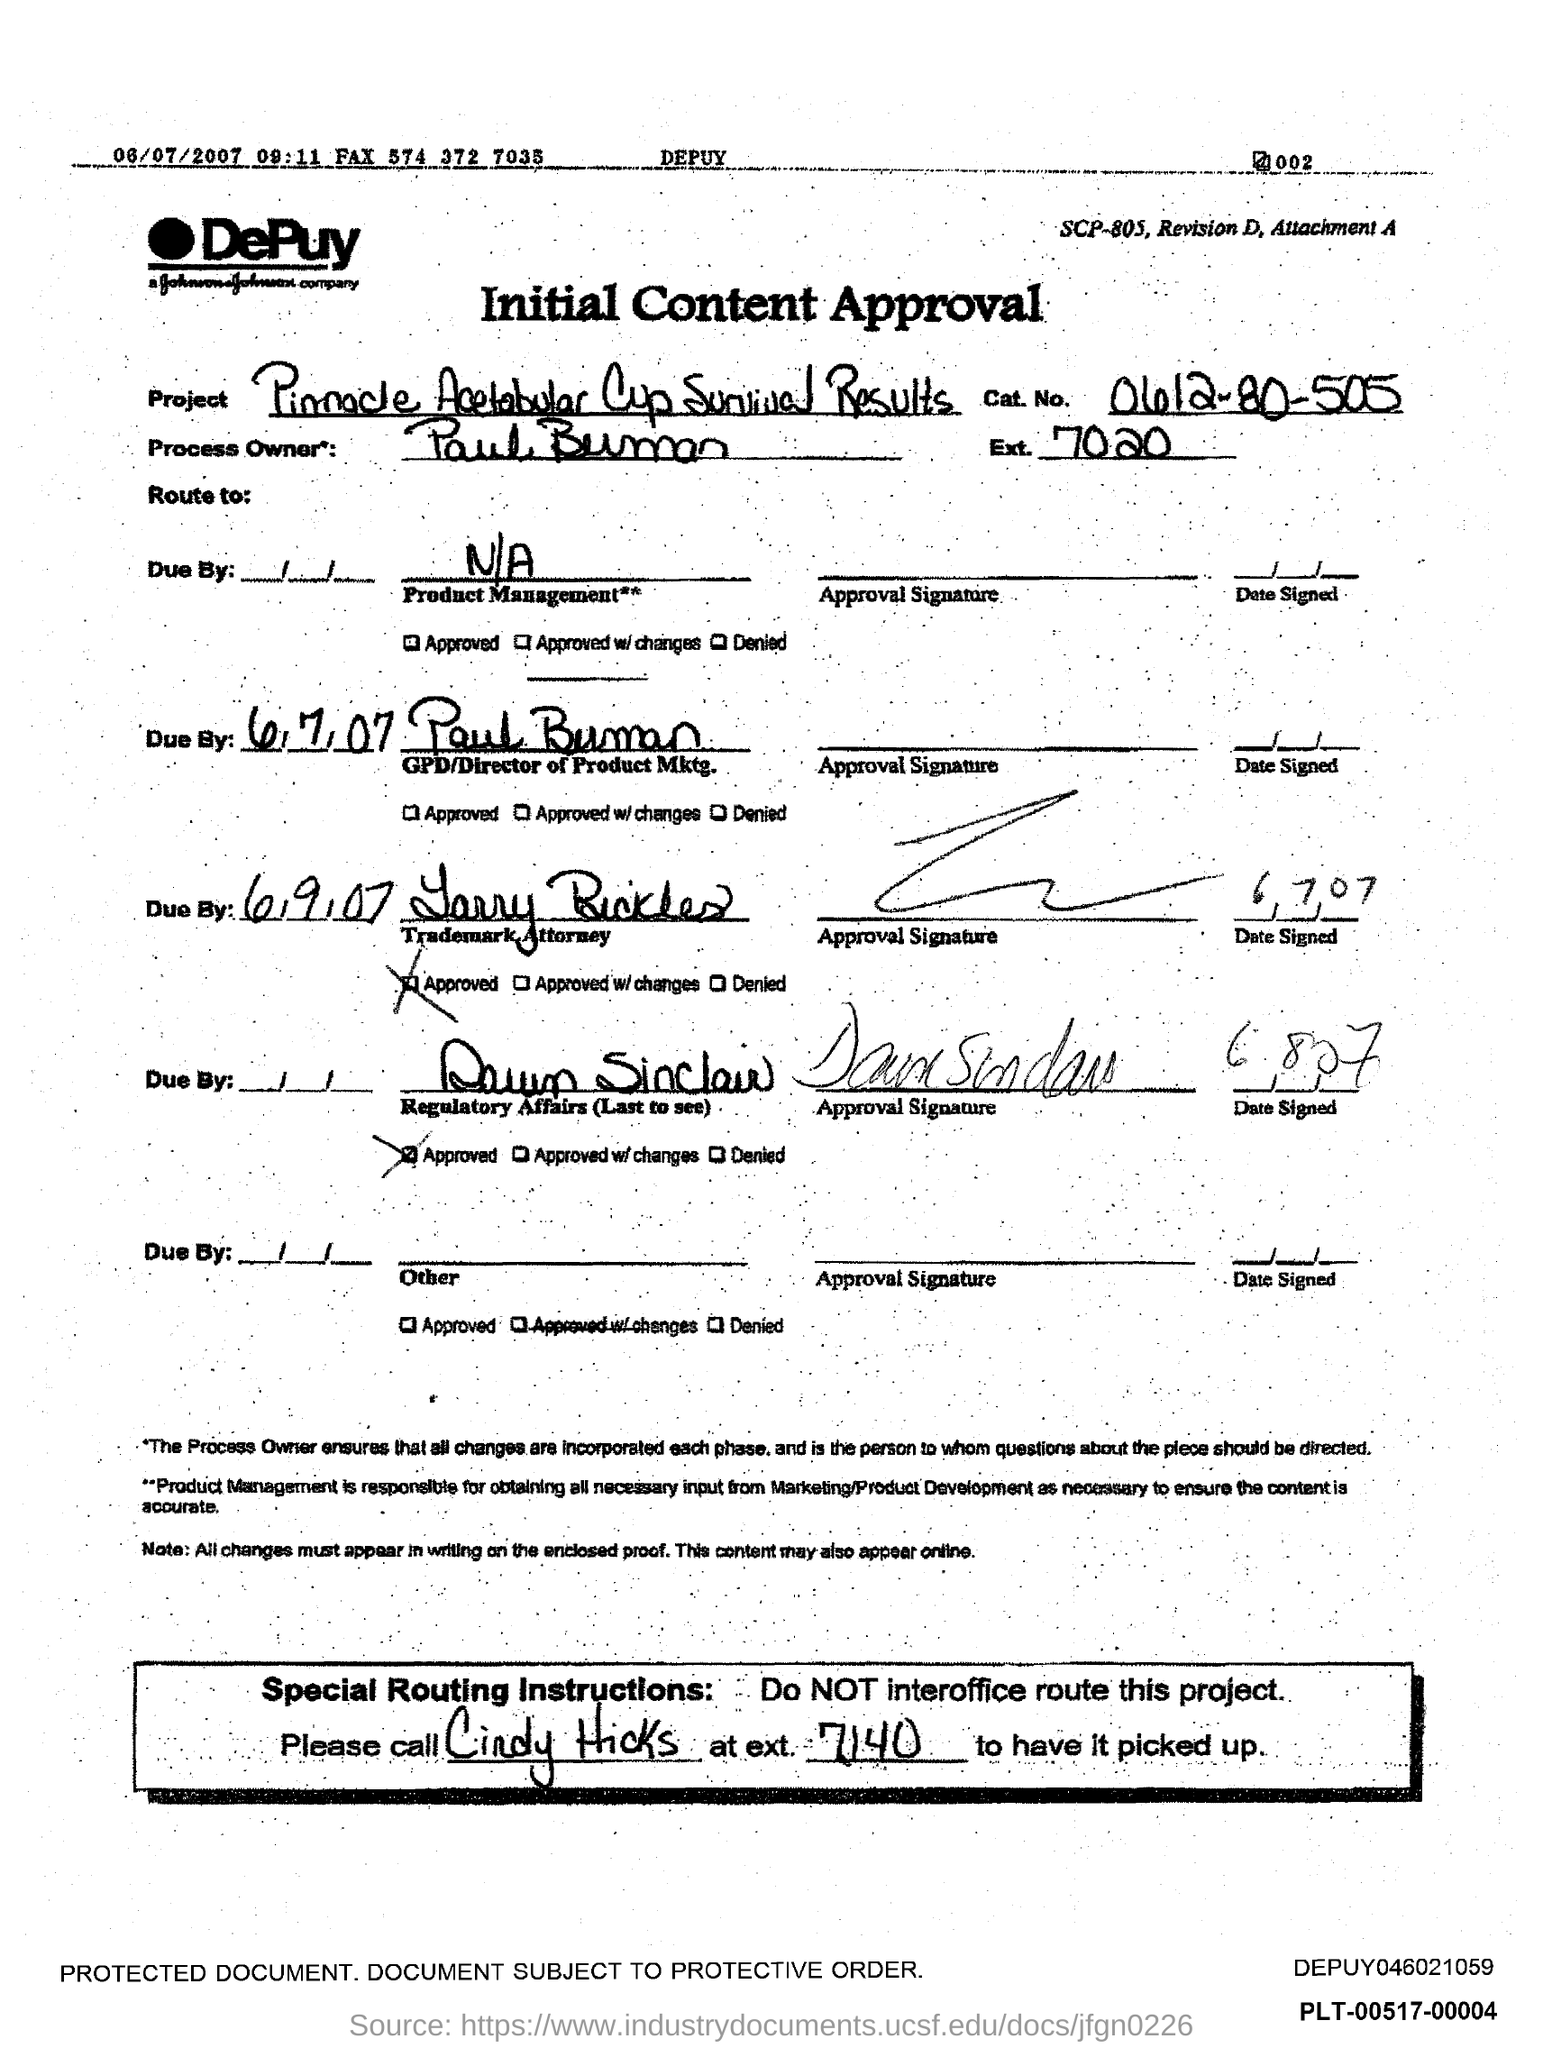List a handful of essential elements in this visual. The Ext. No. of Paul Buman is 7020. This is an initial content approval. The approval mentions Paul Buman as the process owner. The project mentioned in the approval is the Pinnacle Acetabular Cup Survival Results. 